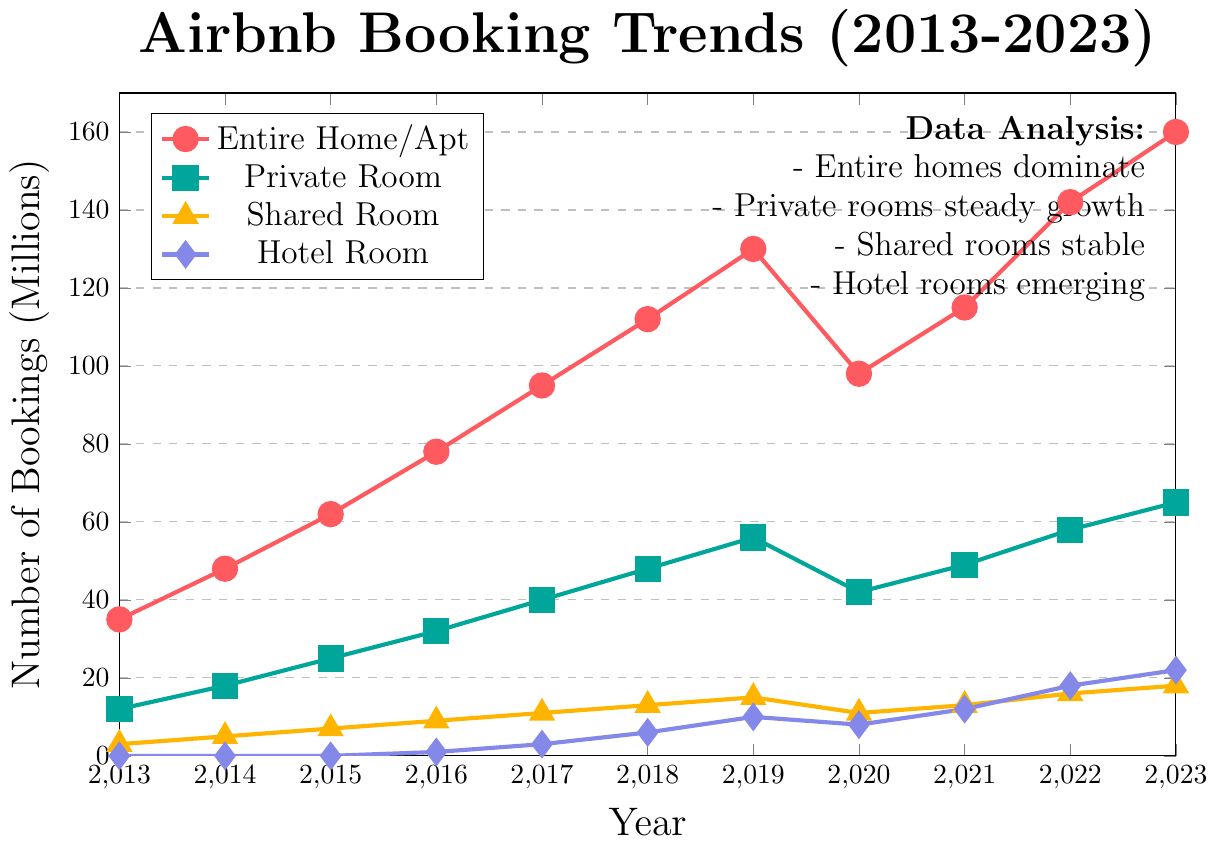What was the trend in the number of bookings for Entire Home/Apt from 2013 to 2023? To determine the trend, observe the red line marking Entire Home/Apt. It shows a consistently increasing pattern over the decade, with only a slight dip in 2020.
Answer: The trend is consistently increasing Which property type had the highest number of bookings in 2023? Look for the highest point on the graph in 2023. The red line (Entire Home/Apt) reaches the highest value at 160 million bookings.
Answer: Entire Home/Apt In which year did Hotel Room bookings surpass Shared Room bookings? Locate the intersection between the purple line (Hotel Room) and the orange line (Shared Room). This happens between 2021 and 2022. Confirm by checking the values: Hotel Room had 12 bookings in 2021, which is still less than 13 for Shared Room, but in 2022, it has 18 compared to 16 for Shared Room.
Answer: 2022 By how much did the number of bookings for Private Rooms increase from 2013 to 2023? Subtract the value in 2013 from the value in 2023 for Private Room (blue line). The values are 65 (2023) and 12 (2013). Therefore, 65 - 12 = 53.
Answer: 53 million Which year experienced the most significant decline in bookings for Entire Home/Apt, and what might have been a probable cause? Look at the red line for Entire Home/Apt and identify the most significant drop between consecutive years. The most substantial decline appears between 2019 (130) to 2020 (98). The likely cause was the COVID-19 pandemic.
Answer: 2020, COVID-19 pandemic Compare the growth rates of Private Room and Shared Room between 2013 and 2023. Which grew faster? Calculate the growth for each property type. For Private Room: (65 - 12) / 12 = 4.42. For Shared Room: (18 - 3) / 3 = 5. Both grew, but Shared Room's relative growth rate is higher despite having smaller increases in booking numbers.
Answer: Shared Room grew faster What is the difference in bookings between the property types with the highest and lowest bookings in 2023? Identify the highest and lowest bookings in 2023. Entire Home/Apt has 160; Shared Room has 18. Subtract the smallest value from the largest: 160 - 18 = 142.
Answer: 142 million Which year did Private Room bookings first exceed 50 million? Trace the blue line for Private Room to find the first year it surpasses 50 million bookings. This occurs in 2019, where bookings reach 56 million.
Answer: 2019 